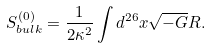<formula> <loc_0><loc_0><loc_500><loc_500>S _ { b u l k } ^ { ( 0 ) } = \frac { 1 } { 2 \kappa ^ { 2 } } \int d ^ { 2 6 } x \sqrt { - G } R .</formula> 